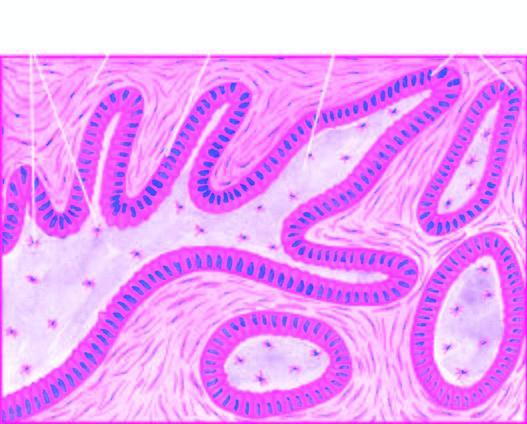what are epithelial follicles composed of?
Answer the question using a single word or phrase. Central area of stellate cells and peripheral layer of cuboidal or columnar cells 